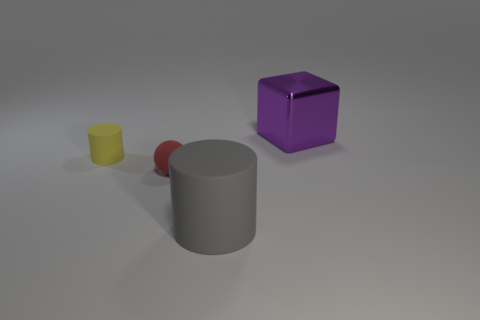How many other things are there of the same color as the large cylinder?
Ensure brevity in your answer.  0. Are there more red things that are in front of the red rubber object than tiny matte things that are to the right of the gray cylinder?
Give a very brief answer. No. How many cubes are either purple objects or big things?
Provide a succinct answer. 1. How many things are either things behind the small yellow cylinder or purple metal balls?
Ensure brevity in your answer.  1. There is a tiny thing that is on the right side of the cylinder to the left of the cylinder on the right side of the small yellow rubber thing; what is its shape?
Give a very brief answer. Sphere. How many small green matte things have the same shape as the yellow rubber object?
Your response must be concise. 0. Do the tiny sphere and the large purple block have the same material?
Offer a very short reply. No. There is a large object that is on the left side of the thing behind the tiny yellow matte thing; what number of balls are on the left side of it?
Provide a short and direct response. 1. Is there a red cylinder made of the same material as the sphere?
Make the answer very short. No. Are there fewer tiny red rubber spheres than tiny cubes?
Your answer should be compact. No. 